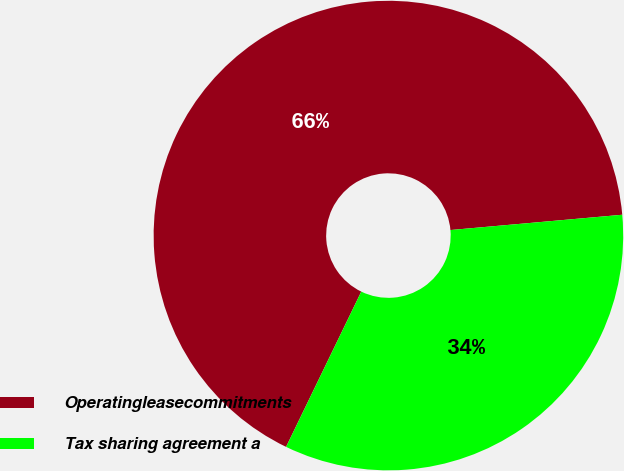Convert chart to OTSL. <chart><loc_0><loc_0><loc_500><loc_500><pie_chart><fcel>Operatingleasecommitments<fcel>Tax sharing agreement a<nl><fcel>66.41%<fcel>33.59%<nl></chart> 